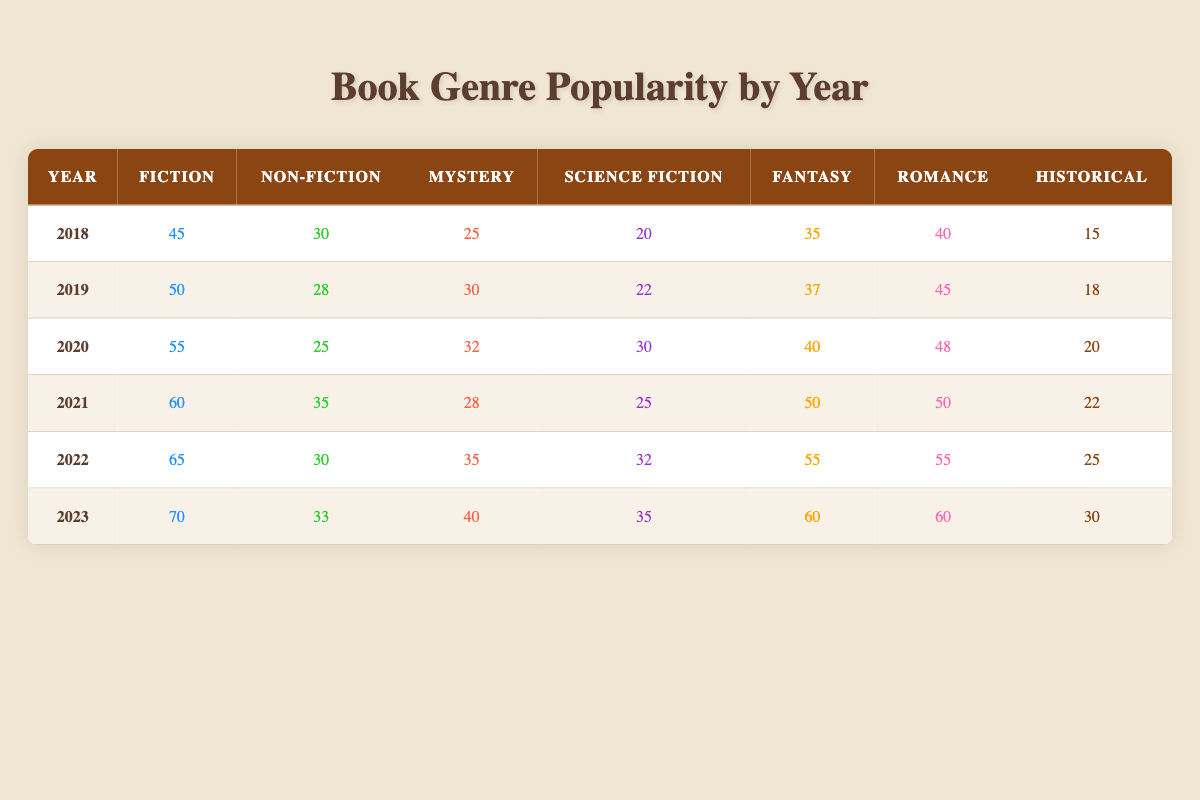What was the popularity of Fiction books in 2021? The popularity of Fiction books for the year 2021 is found in the table by locating the row for that year and looking at the Fiction column. In 2021, the value is 60.
Answer: 60 How many Romance books were popular in 2022 compared to 2018? Looking at the table, we find the values for Romance books in both years. In 2022, the value is 55, while in 2018, it is 40. The difference can be calculated as 55 - 40 = 15.
Answer: 15 In which year was the highest number of Mystery books popular? To find the year with the highest popularity for Mystery books, review all the values in the Mystery column and identify the maximum value. The highest value is 40, found in the year 2023.
Answer: 2023 Was the popularity of Historical books higher in 2019 than in 2020? In 2019, the popularity of Historical books is 18, while in 2020, it is 20. Since 18 is less than 20, the answer is no.
Answer: No What is the average popularity of Science Fiction books over the years from 2018 to 2023? First, sum the popularity values for Science Fiction from each year: 20 + 22 + 30 + 25 + 32 + 35 = 164. Then, divide by the number of years (6) to find the average: 164 / 6 ≈ 27.33.
Answer: 27.33 How many more Fiction books were popular in 2023 compared to 2018? The number of Fiction books in 2023 is 70, and in 2018 it is 45. To find the difference, subtract: 70 - 45 = 25.
Answer: 25 In 2020, which genre had the lowest popularity? To identify the genre with the lowest popularity in 2020, we compare all the genre values: Fiction (55), Non-Fiction (25), Mystery (32), Science Fiction (30), Fantasy (40), Romance (48), Historical (20). The lowest is Non-Fiction with 25.
Answer: Non-Fiction What trend can be observed in the popularity of Fantasy books from 2018 to 2023? By analyzing the values for Fantasy over the years: 35, 37, 40, 50, 55, 60, we see an increasing trend. Thus, the trend for Fantasy books is upward.
Answer: Upward trend What is the total popularity of Non-Fiction books from 2018 to 2023? We need to add the Non-Fiction values for each year: 30 + 28 + 25 + 35 + 30 + 33 = 181. This gives us the total popularity of Non-Fiction books.
Answer: 181 